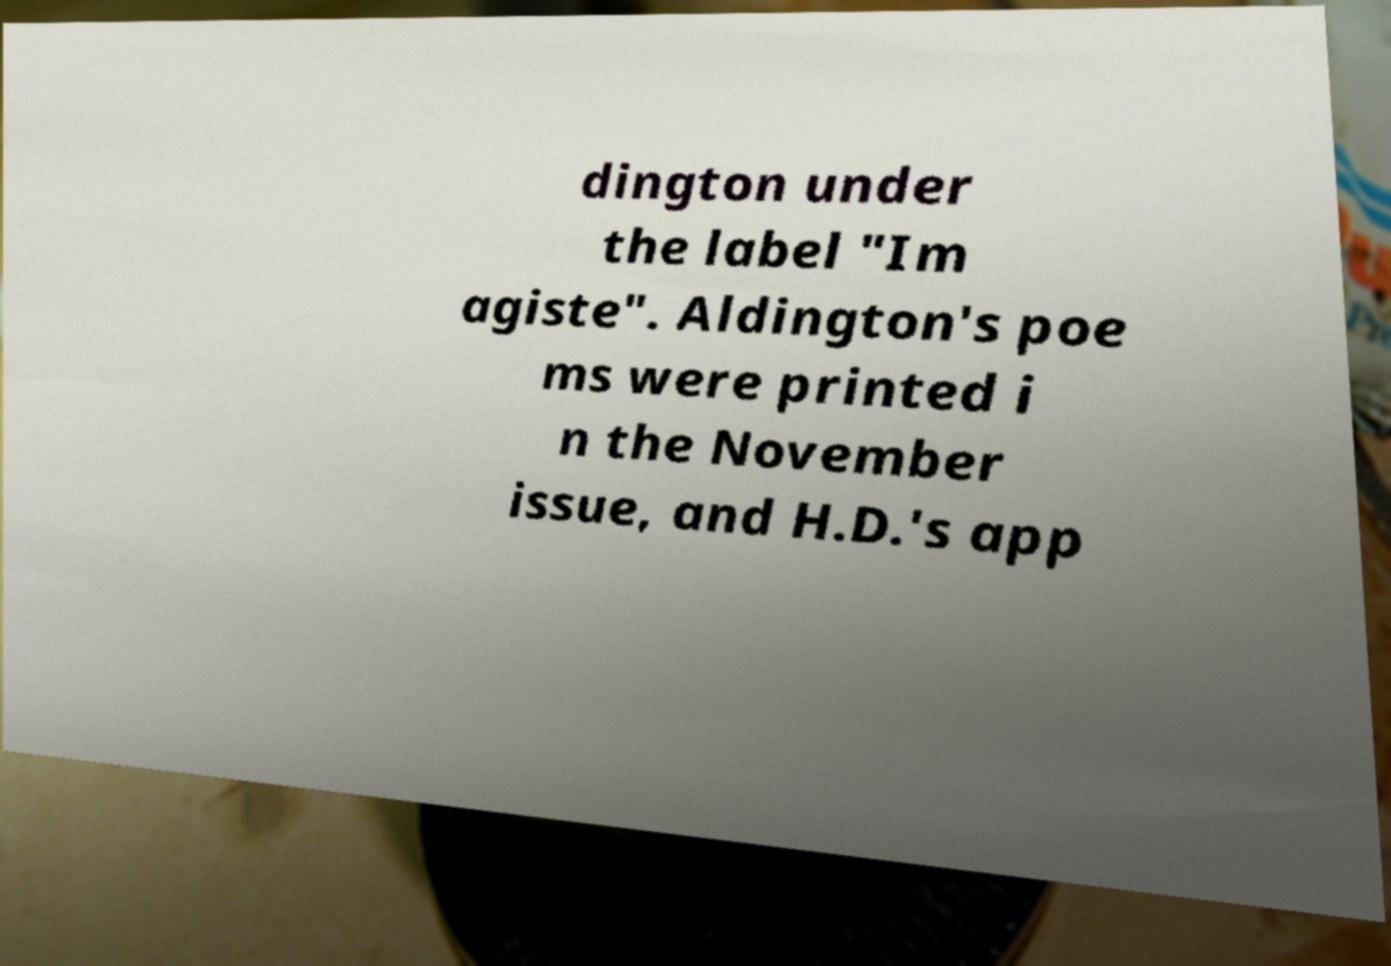Could you assist in decoding the text presented in this image and type it out clearly? dington under the label "Im agiste". Aldington's poe ms were printed i n the November issue, and H.D.'s app 